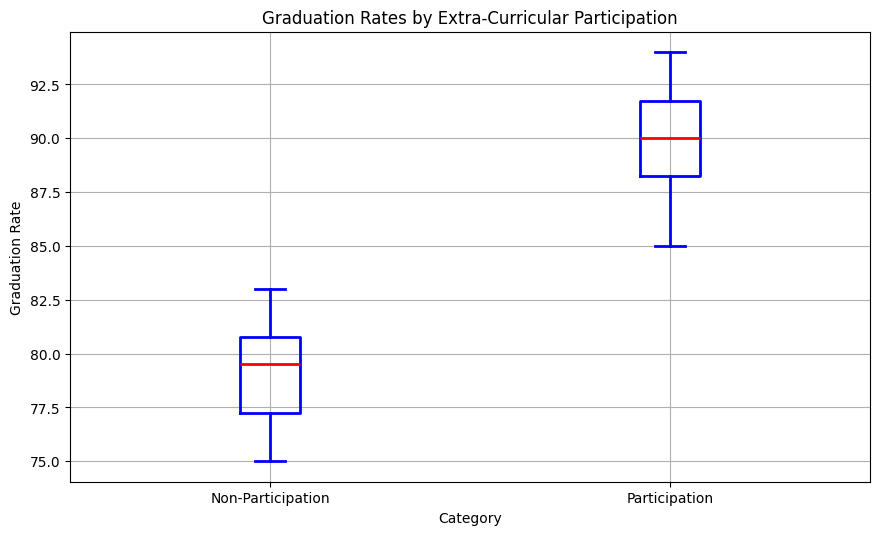What is the median graduation rate for students who participate in extra-curricular activities? The median is indicated by the red line inside the box for the 'Participation' category.
Answer: 90 Which group has a higher median graduation rate? Compare the red lines inside the boxes for both categories. The 'Participation' group has a higher median graduation rate than the 'Non-Participation' group.
Answer: Participation What is the interquartile range (IQR) for the non-participation group? The IQR is the difference between the third quartile (Q3) and the first quartile (Q1). For 'Non-Participation', find Q3 (top of the box) and Q1 (bottom of the box), then subtract Q1 from Q3.
Answer: 4 Which group has a higher variability in graduation rates? Compare the lengths of the boxes (indicating IQR) and the total range (including whiskers and fliers) for both categories. 'Non-Participation' shows a wider box and longer whiskers.
Answer: Non-Participation What is the range of graduation rates for students with non-participation in activities? The range is the difference between the maximum and minimum whisker points for 'Non-Participation'.
Answer: 83 - 75 = 8 Are there any outliers in the graduation rates for either group? Outliers are indicated by green dots outside the whiskers. Check for the presence of any green dots.
Answer: No What percentage of students participating in extra-curricular activities have a graduation rate above 90? Count the data points above 90 within the 'Participation' group and divide by the total number of data points in that group. There are 4 data points (92, 91, 94, 93) above 90 out of 10.
Answer: 40% How does the median graduation rate for non-participating students compare to the first quartile graduation rate for participating students? Compare the red line inside the box for 'Non-Participation' to the bottom of the box for 'Participation'. The median for 'Non-Participation' is 79, and Q1 for 'Participation' is around 88.
Answer: The median for Non-Participation is lower What does the absence of outliers in both groups suggest? Outliers indicate exceptionally high or low data points. The absence of outliers suggests more consistency and fewer extreme values within each group.
Answer: Consistent data Which group has a narrower interquartile range? Compare the widths of the boxes for both categories. The 'Participation' group has a narrower box, indicating a smaller IQR.
Answer: Participation 